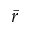Convert formula to latex. <formula><loc_0><loc_0><loc_500><loc_500>\bar { r }</formula> 